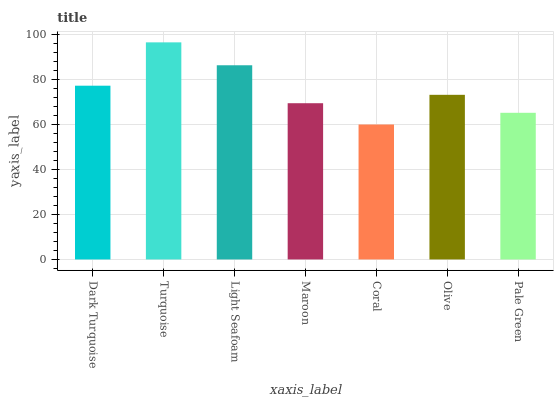Is Light Seafoam the minimum?
Answer yes or no. No. Is Light Seafoam the maximum?
Answer yes or no. No. Is Turquoise greater than Light Seafoam?
Answer yes or no. Yes. Is Light Seafoam less than Turquoise?
Answer yes or no. Yes. Is Light Seafoam greater than Turquoise?
Answer yes or no. No. Is Turquoise less than Light Seafoam?
Answer yes or no. No. Is Olive the high median?
Answer yes or no. Yes. Is Olive the low median?
Answer yes or no. Yes. Is Light Seafoam the high median?
Answer yes or no. No. Is Maroon the low median?
Answer yes or no. No. 